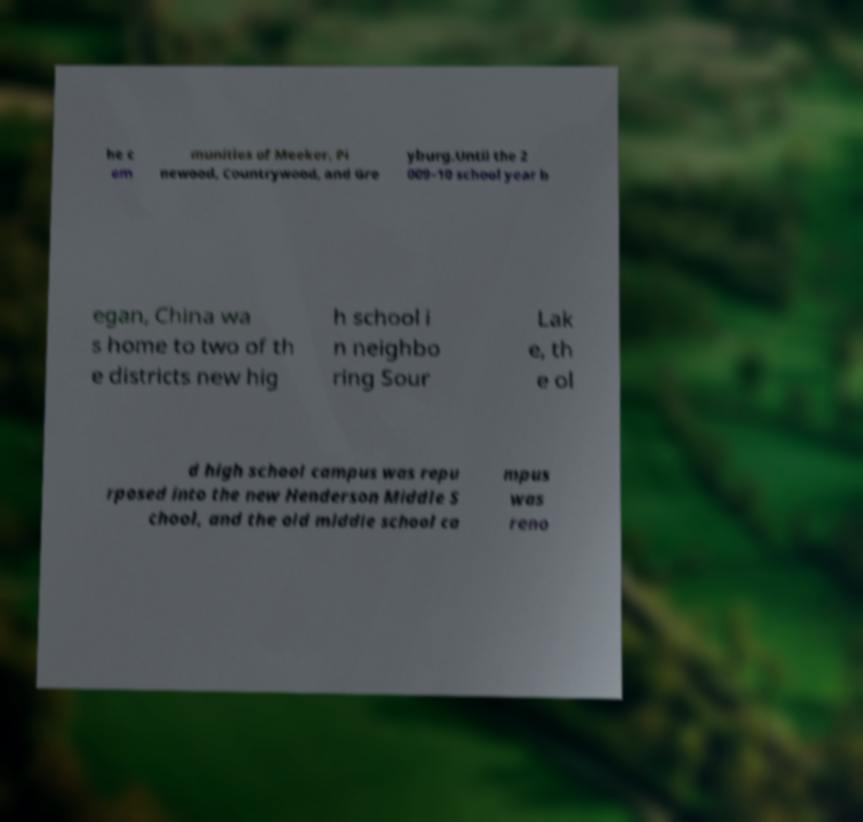Please identify and transcribe the text found in this image. he c om munities of Meeker, Pi newood, Countrywood, and Gre yburg.Until the 2 009–10 school year b egan, China wa s home to two of th e districts new hig h school i n neighbo ring Sour Lak e, th e ol d high school campus was repu rposed into the new Henderson Middle S chool, and the old middle school ca mpus was reno 